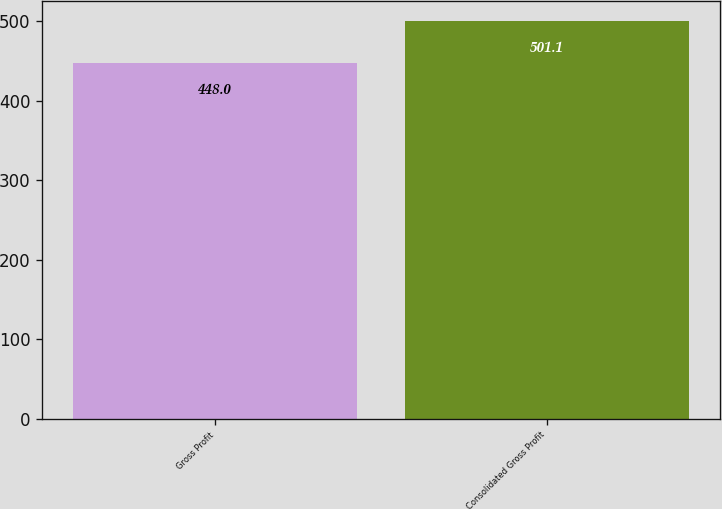<chart> <loc_0><loc_0><loc_500><loc_500><bar_chart><fcel>Gross Profit<fcel>Consolidated Gross Profit<nl><fcel>448<fcel>501.1<nl></chart> 